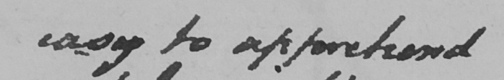Can you tell me what this handwritten text says? easy to apprehend 